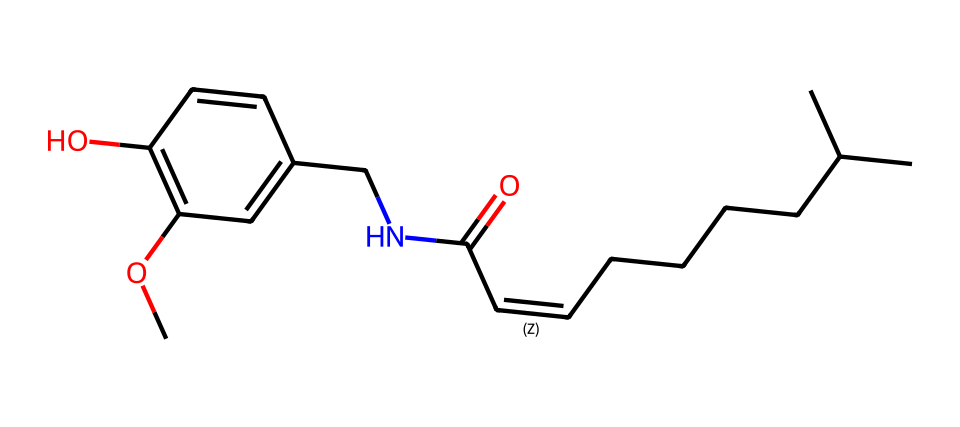what is the name of this compound? This SMILES structure corresponds to capsaicin, which is the active compound found in chili peppers responsible for their spiciness.
Answer: capsaicin how many carbon atoms are in this structure? In the provided SMILES, if we count the 'C' characters, there are a total of 18 carbon atoms present.
Answer: 18 what type of chemical compound is capsaicin classified as? Capsaicin contains a benzene ring in its structure, characteristic of aromatic compounds, making it an aromatic amide.
Answer: aromatic amide how many nitrogen atoms are in this compound? By checking the SMILES representation, we can see there is one 'N' character present, indicating there is one nitrogen atom in the structure.
Answer: 1 what functional group is present in this structure that indicates it can form hydrogen bonds? The presence of the hydroxyl group (-OH) in the structure, indicated by the 'O' connected to a carbon, allows for hydrogen bonding capabilities.
Answer: hydroxyl group which part of the structure is mainly responsible for its spiciness? The vanillyl group, represented in the structure, specifically contributes to the pungency and spiciness of capsaicin.
Answer: vanillyl group what is the total number of double bonds in this compound? By examining the double bond indicators ('=' and '/') in the SMILES structure, we can identify that there are three double bonds present in capsaicin.
Answer: 3 